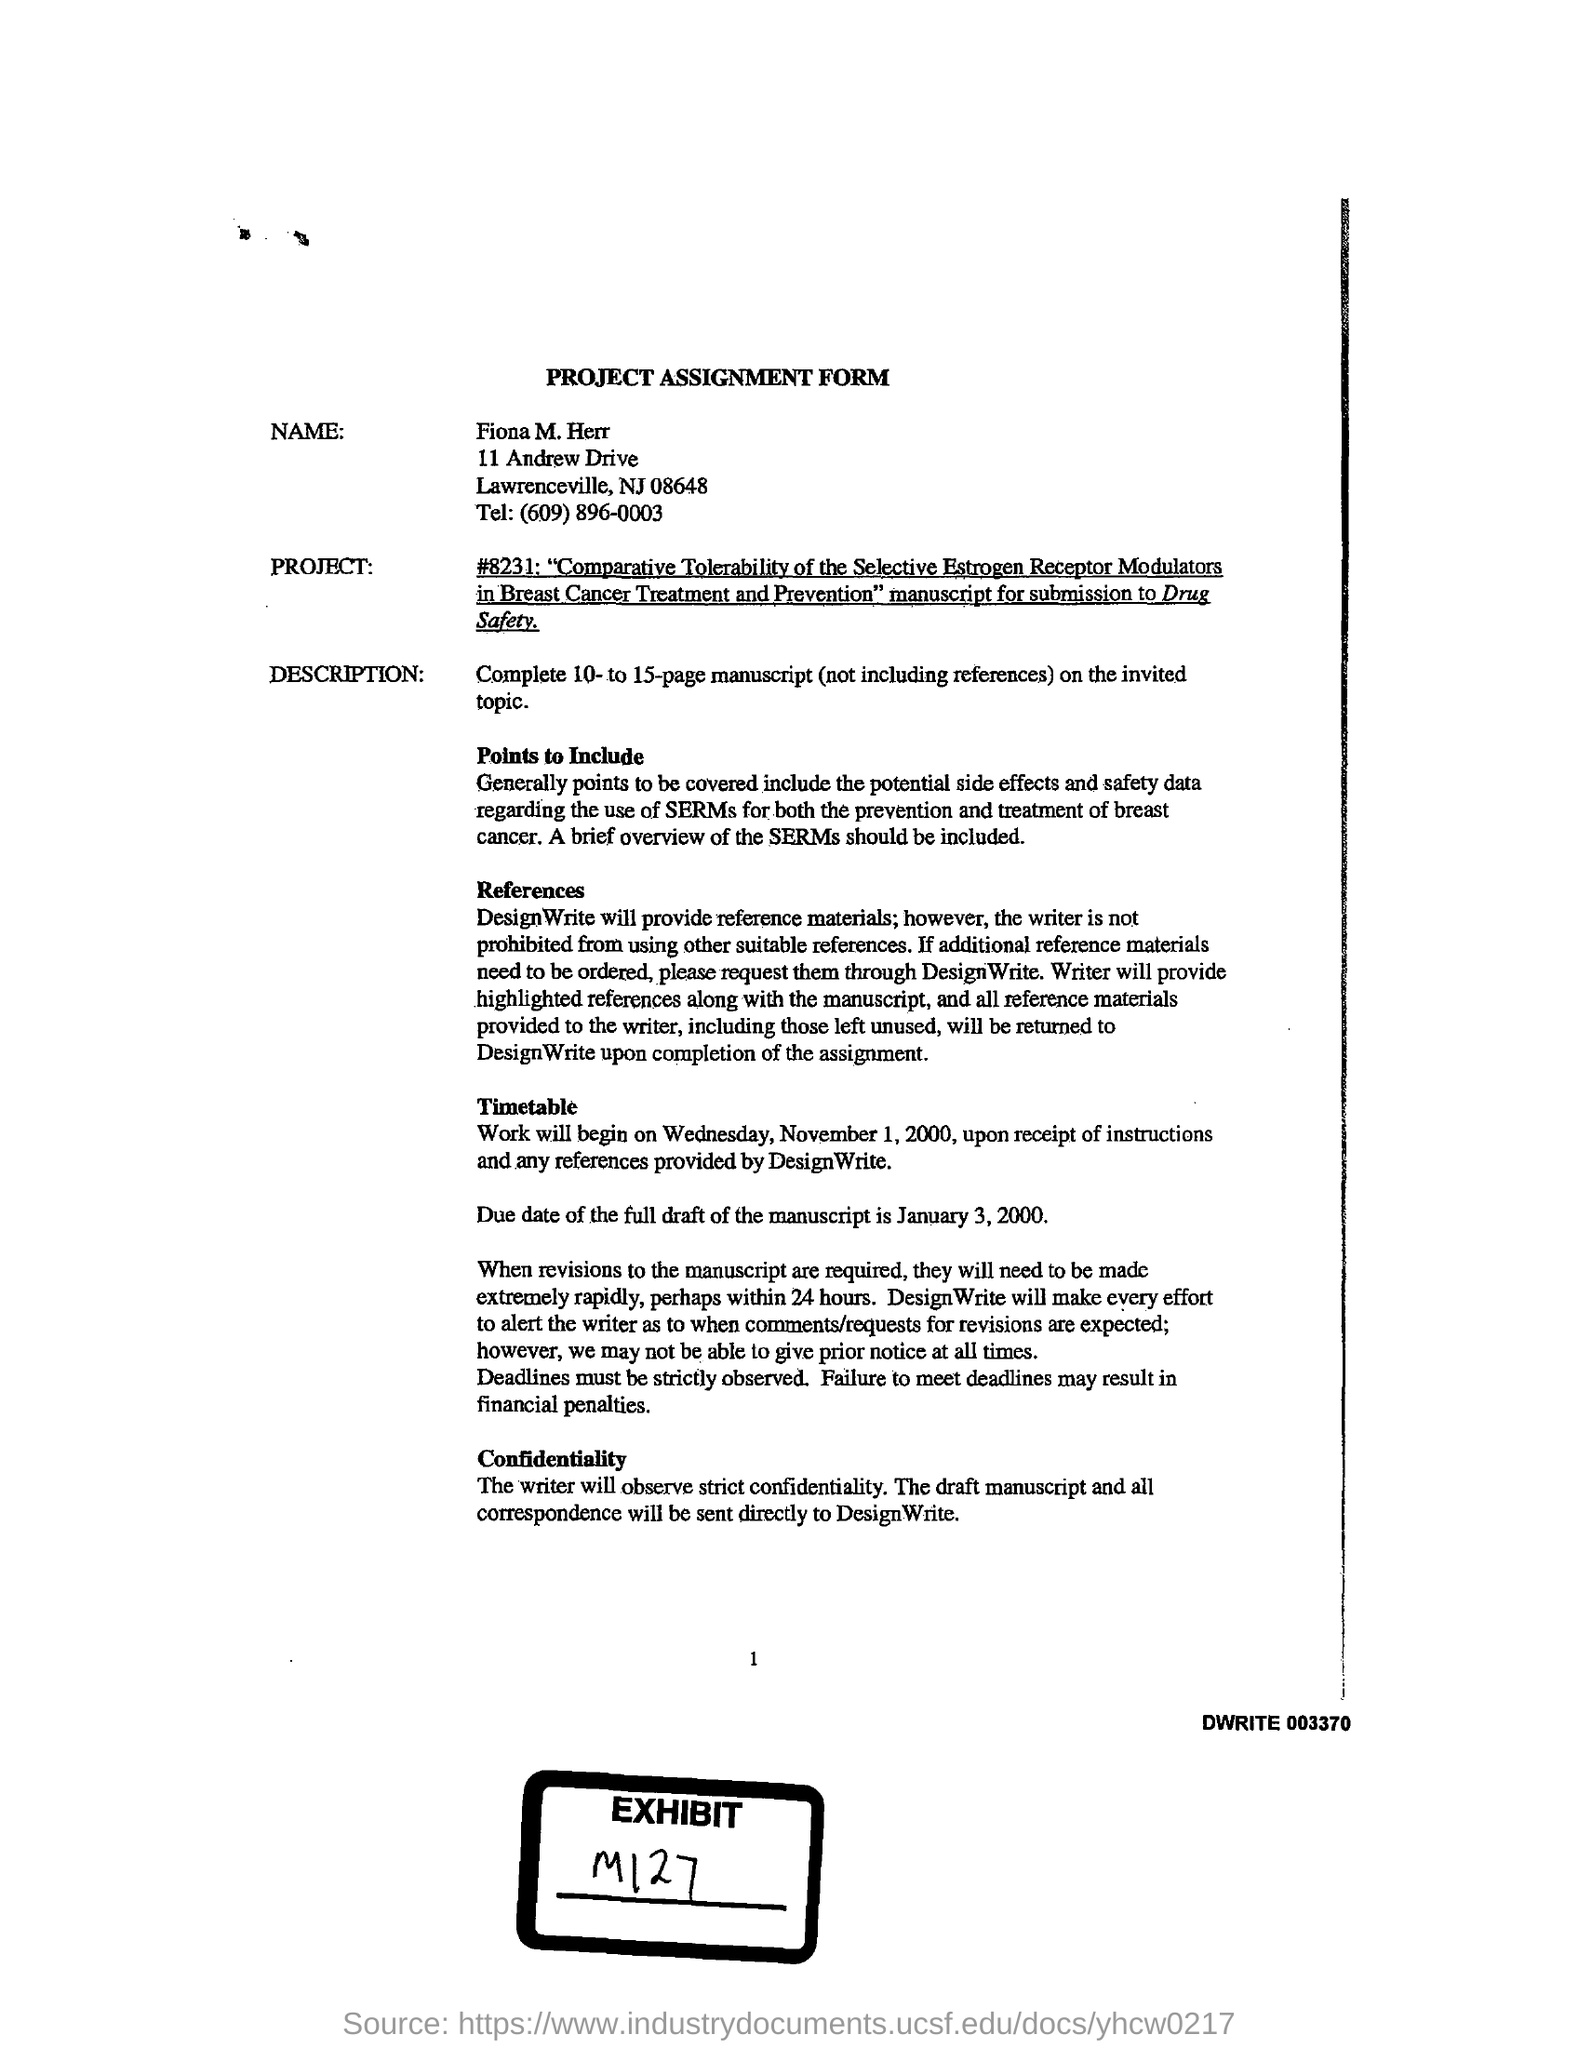Indicate a few pertinent items in this graphic. The telephone number provided on the assignment form is (609) 896-0003. The full draft of the manuscript is due on January 3, 2000. Fiona M. Herr's name was written on the project assignment form. 